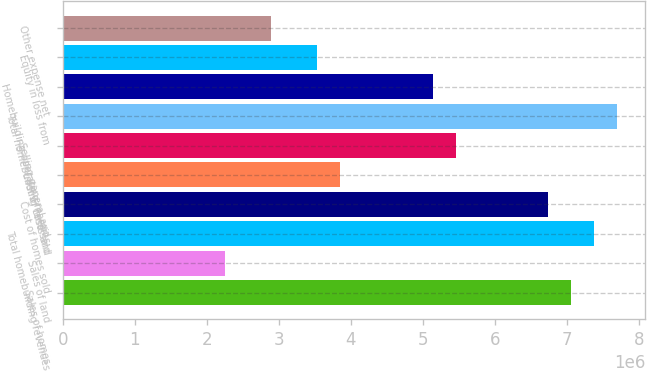Convert chart. <chart><loc_0><loc_0><loc_500><loc_500><bar_chart><fcel>Sales of homes<fcel>Sales of land<fcel>Total homebuilding revenues<fcel>Cost of homes sold<fcel>Cost of land sold<fcel>Selling general and<fcel>Total homebuilding costs and<fcel>Homebuilding operating margins<fcel>Equity in loss from<fcel>Other expense net<nl><fcel>7.06285e+06<fcel>2.24727e+06<fcel>7.38389e+06<fcel>6.74181e+06<fcel>3.85246e+06<fcel>5.45766e+06<fcel>7.70493e+06<fcel>5.13662e+06<fcel>3.53142e+06<fcel>2.88935e+06<nl></chart> 